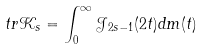<formula> <loc_0><loc_0><loc_500><loc_500>t r \mathcal { K } _ { s } = \int _ { 0 } ^ { \infty } \mathcal { J } _ { 2 s - 1 } ( 2 t ) d m ( t )</formula> 